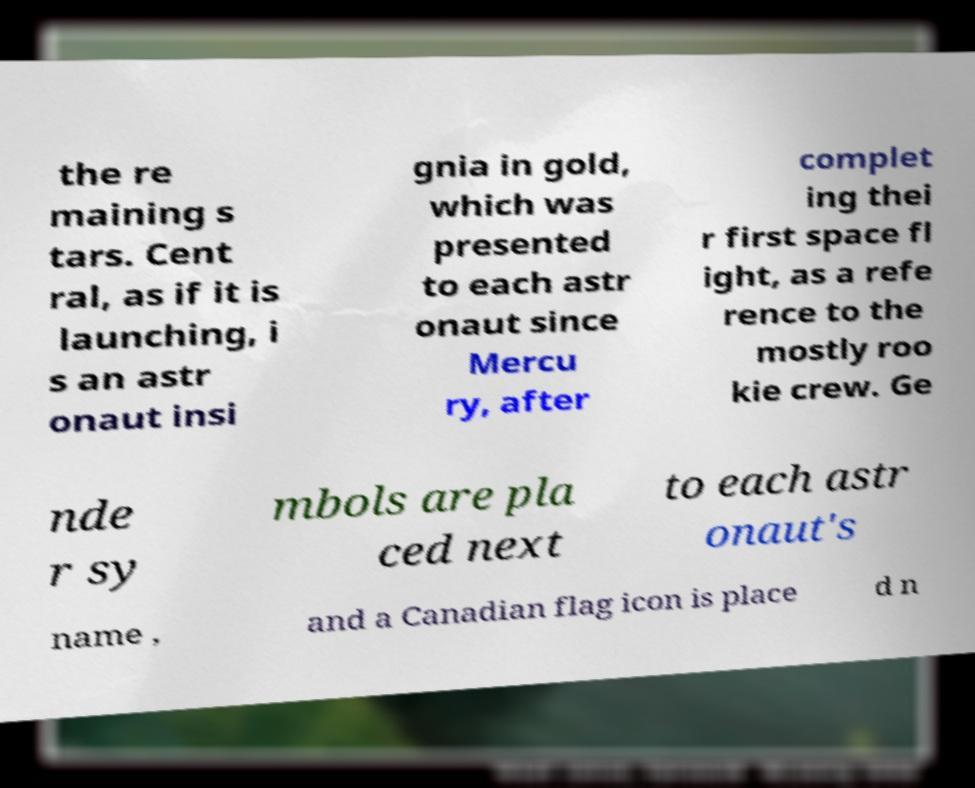For documentation purposes, I need the text within this image transcribed. Could you provide that? the re maining s tars. Cent ral, as if it is launching, i s an astr onaut insi gnia in gold, which was presented to each astr onaut since Mercu ry, after complet ing thei r first space fl ight, as a refe rence to the mostly roo kie crew. Ge nde r sy mbols are pla ced next to each astr onaut's name , and a Canadian flag icon is place d n 